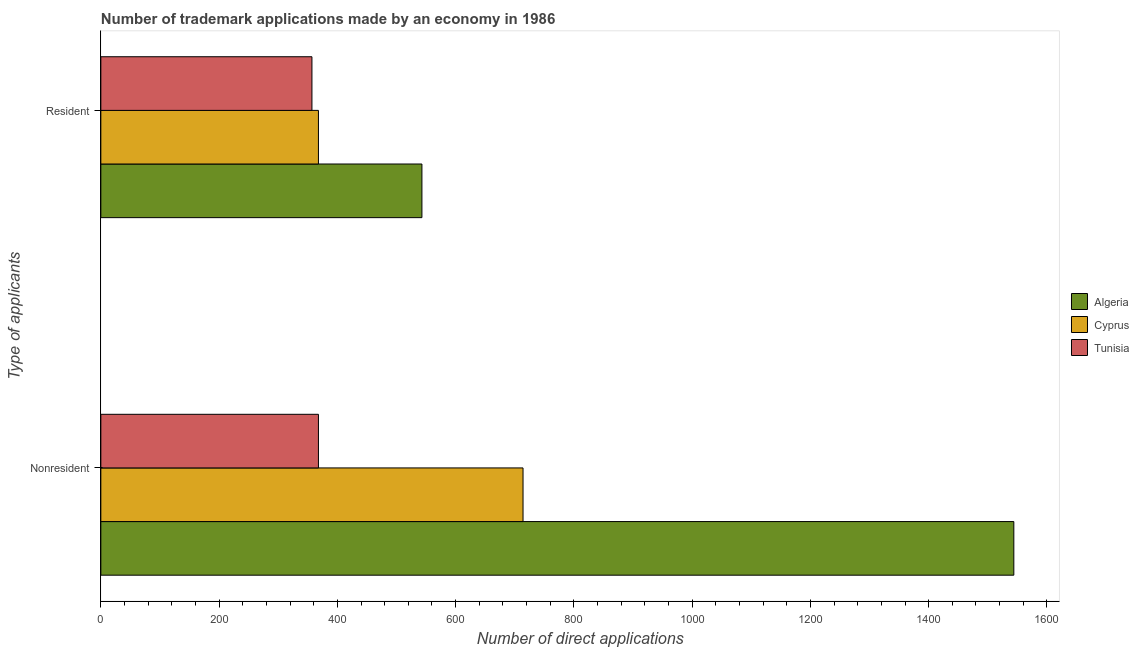How many different coloured bars are there?
Keep it short and to the point. 3. How many bars are there on the 2nd tick from the top?
Give a very brief answer. 3. How many bars are there on the 1st tick from the bottom?
Give a very brief answer. 3. What is the label of the 1st group of bars from the top?
Give a very brief answer. Resident. What is the number of trademark applications made by non residents in Algeria?
Give a very brief answer. 1544. Across all countries, what is the maximum number of trademark applications made by non residents?
Keep it short and to the point. 1544. Across all countries, what is the minimum number of trademark applications made by non residents?
Give a very brief answer. 368. In which country was the number of trademark applications made by non residents maximum?
Give a very brief answer. Algeria. In which country was the number of trademark applications made by non residents minimum?
Your answer should be very brief. Tunisia. What is the total number of trademark applications made by residents in the graph?
Offer a very short reply. 1268. What is the difference between the number of trademark applications made by non residents in Tunisia and that in Cyprus?
Offer a terse response. -346. What is the difference between the number of trademark applications made by residents in Cyprus and the number of trademark applications made by non residents in Algeria?
Provide a succinct answer. -1176. What is the average number of trademark applications made by non residents per country?
Offer a terse response. 875.33. What is the difference between the number of trademark applications made by residents and number of trademark applications made by non residents in Cyprus?
Your response must be concise. -346. What is the ratio of the number of trademark applications made by residents in Algeria to that in Cyprus?
Keep it short and to the point. 1.48. In how many countries, is the number of trademark applications made by non residents greater than the average number of trademark applications made by non residents taken over all countries?
Make the answer very short. 1. What does the 3rd bar from the top in Nonresident represents?
Offer a very short reply. Algeria. What does the 2nd bar from the bottom in Nonresident represents?
Offer a terse response. Cyprus. How many bars are there?
Your answer should be compact. 6. How many countries are there in the graph?
Provide a short and direct response. 3. Are the values on the major ticks of X-axis written in scientific E-notation?
Provide a succinct answer. No. Does the graph contain any zero values?
Your response must be concise. No. How are the legend labels stacked?
Offer a very short reply. Vertical. What is the title of the graph?
Your answer should be compact. Number of trademark applications made by an economy in 1986. Does "Middle East & North Africa (developing only)" appear as one of the legend labels in the graph?
Your response must be concise. No. What is the label or title of the X-axis?
Your answer should be compact. Number of direct applications. What is the label or title of the Y-axis?
Offer a very short reply. Type of applicants. What is the Number of direct applications in Algeria in Nonresident?
Your answer should be very brief. 1544. What is the Number of direct applications of Cyprus in Nonresident?
Offer a terse response. 714. What is the Number of direct applications of Tunisia in Nonresident?
Provide a succinct answer. 368. What is the Number of direct applications of Algeria in Resident?
Your answer should be compact. 543. What is the Number of direct applications in Cyprus in Resident?
Provide a short and direct response. 368. What is the Number of direct applications of Tunisia in Resident?
Offer a terse response. 357. Across all Type of applicants, what is the maximum Number of direct applications in Algeria?
Your answer should be compact. 1544. Across all Type of applicants, what is the maximum Number of direct applications of Cyprus?
Keep it short and to the point. 714. Across all Type of applicants, what is the maximum Number of direct applications of Tunisia?
Offer a very short reply. 368. Across all Type of applicants, what is the minimum Number of direct applications in Algeria?
Provide a succinct answer. 543. Across all Type of applicants, what is the minimum Number of direct applications of Cyprus?
Your answer should be compact. 368. Across all Type of applicants, what is the minimum Number of direct applications of Tunisia?
Keep it short and to the point. 357. What is the total Number of direct applications in Algeria in the graph?
Provide a succinct answer. 2087. What is the total Number of direct applications of Cyprus in the graph?
Provide a succinct answer. 1082. What is the total Number of direct applications in Tunisia in the graph?
Provide a short and direct response. 725. What is the difference between the Number of direct applications in Algeria in Nonresident and that in Resident?
Offer a very short reply. 1001. What is the difference between the Number of direct applications in Cyprus in Nonresident and that in Resident?
Give a very brief answer. 346. What is the difference between the Number of direct applications in Tunisia in Nonresident and that in Resident?
Your answer should be compact. 11. What is the difference between the Number of direct applications in Algeria in Nonresident and the Number of direct applications in Cyprus in Resident?
Keep it short and to the point. 1176. What is the difference between the Number of direct applications of Algeria in Nonresident and the Number of direct applications of Tunisia in Resident?
Make the answer very short. 1187. What is the difference between the Number of direct applications in Cyprus in Nonresident and the Number of direct applications in Tunisia in Resident?
Provide a succinct answer. 357. What is the average Number of direct applications of Algeria per Type of applicants?
Your response must be concise. 1043.5. What is the average Number of direct applications in Cyprus per Type of applicants?
Give a very brief answer. 541. What is the average Number of direct applications of Tunisia per Type of applicants?
Give a very brief answer. 362.5. What is the difference between the Number of direct applications in Algeria and Number of direct applications in Cyprus in Nonresident?
Give a very brief answer. 830. What is the difference between the Number of direct applications in Algeria and Number of direct applications in Tunisia in Nonresident?
Your answer should be very brief. 1176. What is the difference between the Number of direct applications in Cyprus and Number of direct applications in Tunisia in Nonresident?
Ensure brevity in your answer.  346. What is the difference between the Number of direct applications of Algeria and Number of direct applications of Cyprus in Resident?
Your answer should be very brief. 175. What is the difference between the Number of direct applications of Algeria and Number of direct applications of Tunisia in Resident?
Your response must be concise. 186. What is the ratio of the Number of direct applications in Algeria in Nonresident to that in Resident?
Your answer should be very brief. 2.84. What is the ratio of the Number of direct applications of Cyprus in Nonresident to that in Resident?
Provide a short and direct response. 1.94. What is the ratio of the Number of direct applications in Tunisia in Nonresident to that in Resident?
Provide a succinct answer. 1.03. What is the difference between the highest and the second highest Number of direct applications of Algeria?
Offer a very short reply. 1001. What is the difference between the highest and the second highest Number of direct applications of Cyprus?
Keep it short and to the point. 346. What is the difference between the highest and the lowest Number of direct applications of Algeria?
Offer a terse response. 1001. What is the difference between the highest and the lowest Number of direct applications in Cyprus?
Your answer should be very brief. 346. What is the difference between the highest and the lowest Number of direct applications of Tunisia?
Your answer should be compact. 11. 